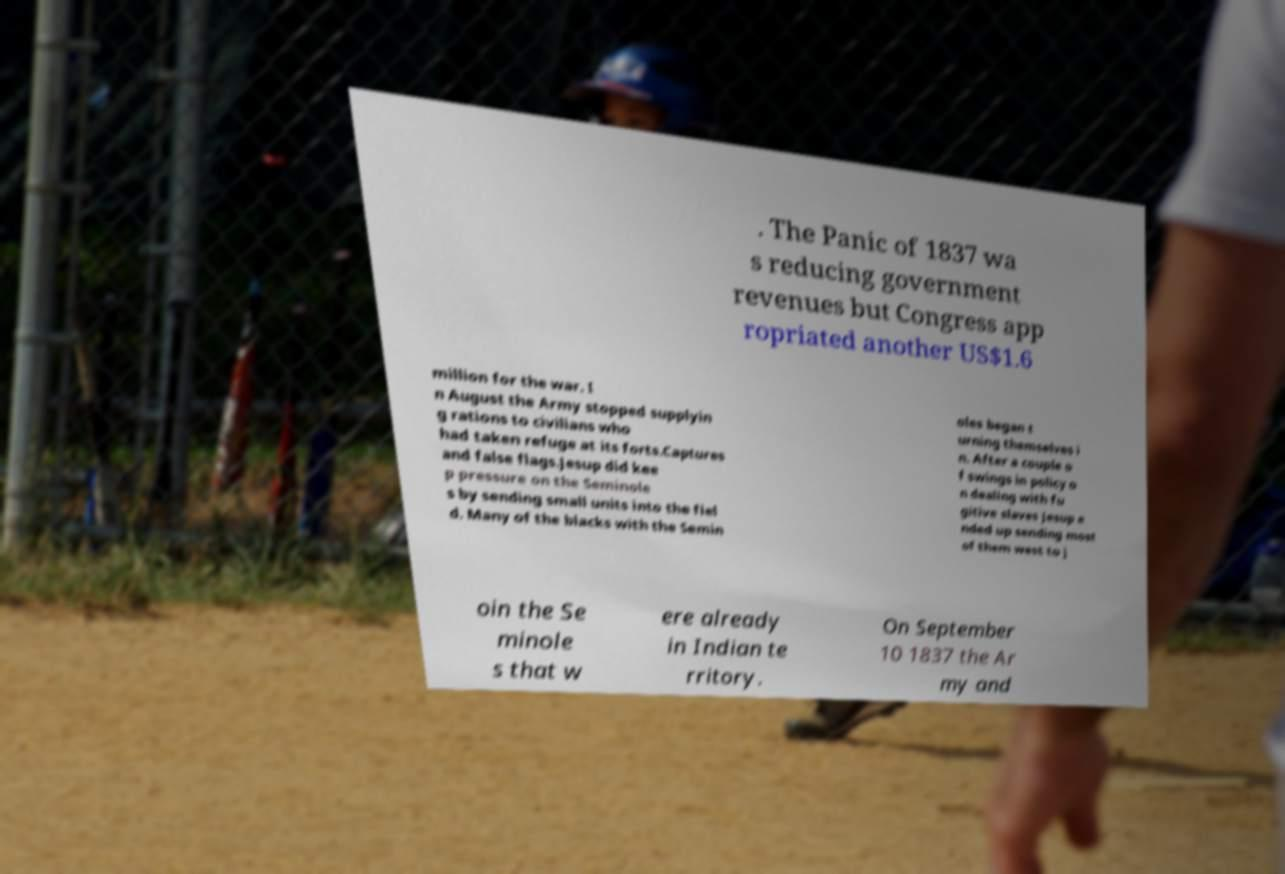There's text embedded in this image that I need extracted. Can you transcribe it verbatim? . The Panic of 1837 wa s reducing government revenues but Congress app ropriated another US$1.6 million for the war. I n August the Army stopped supplyin g rations to civilians who had taken refuge at its forts.Captures and false flags.Jesup did kee p pressure on the Seminole s by sending small units into the fiel d. Many of the blacks with the Semin oles began t urning themselves i n. After a couple o f swings in policy o n dealing with fu gitive slaves Jesup e nded up sending most of them west to j oin the Se minole s that w ere already in Indian te rritory. On September 10 1837 the Ar my and 